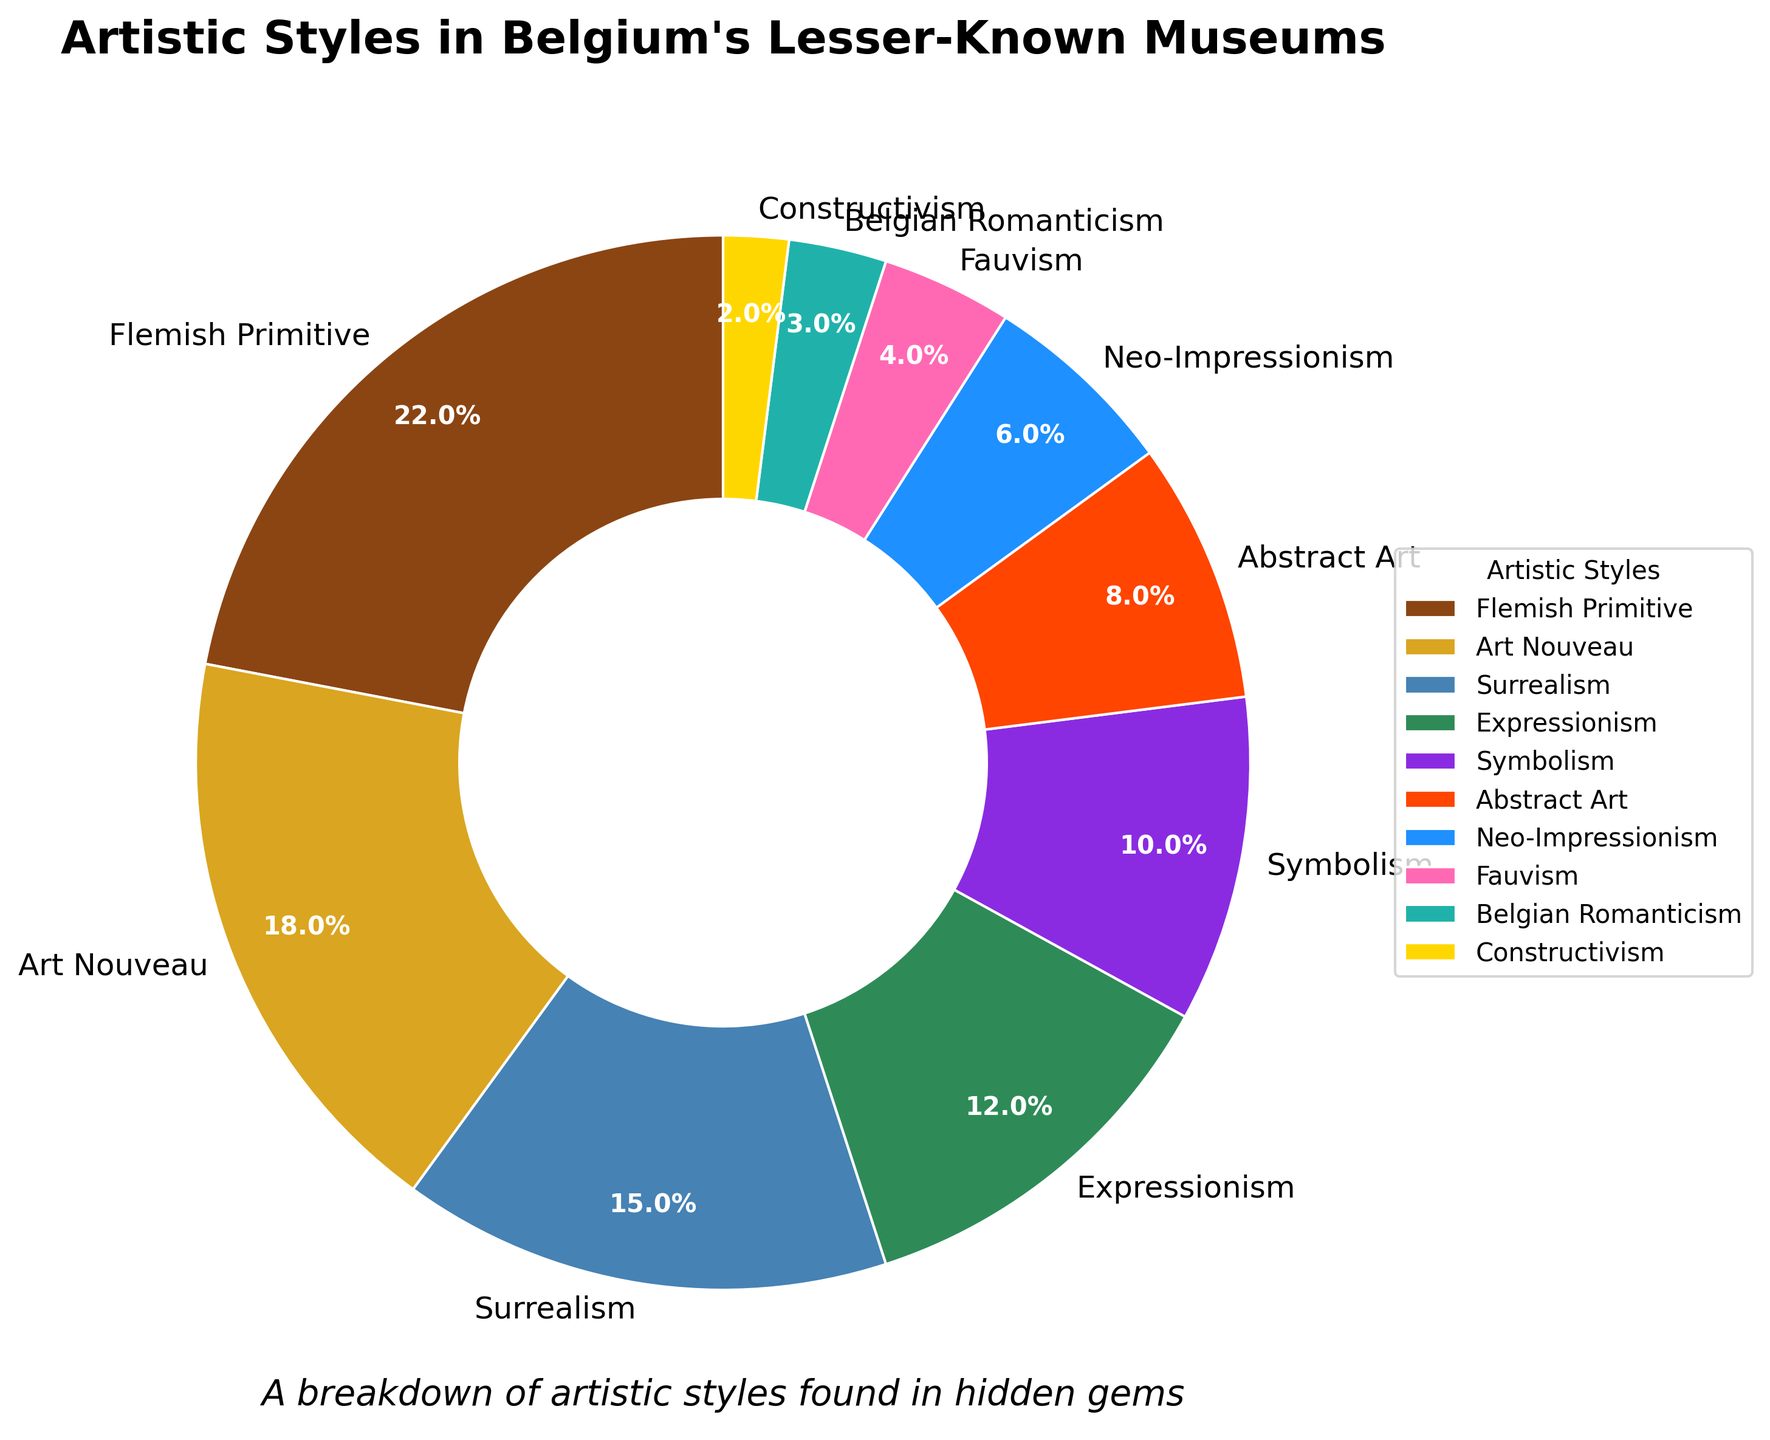What percentage of the artistic styles is represented by Flemish Primitive and Symbolism together? Add the percentages of Flemish Primitive (22%) and Symbolism (10%) to get the combined representation: 22 + 10 = 32
Answer: 32% Which artistic style has the smallest representation? By looking at the pie chart, Constructivism has the smallest percentage at 2%
Answer: Constructivism Which is more predominant in the lesser-known museums, Art Nouveau or Expressionism? Art Nouveau has a percentage of 18% and Expressionism has 12%, so Art Nouveau is more predominant
Answer: Art Nouveau How much more percentage does Surrealism have compared to Belgian Romanticism? Surrealism has 15% and Belgian Romanticism has 3%. The difference is 15 - 3 = 12
Answer: 12% What is the combined percentage of all styles that have a representation of less than 10%? The styles with less than 10% are Symbolism (10%), Abstract Art (8%), Neo-Impressionism (6%), Fauvism (4%), Belgian Romanticism (3%), and Constructivism (2%). Add them up: 10 + 8 + 6 + 4 + 3 + 2 = 33
Answer: 33% Which has a higher percentage, Fauvism or Neo-Impressionism, and by how much? Neo-Impressionism has 6% and Fauvism has 4%, so Neo-Impressionism is higher by 6 - 4 = 2
Answer: Neo-Impressionism, 2% What artistic styles make up a total of 40% if added together? Combining Expressionism (12%), Symbolism (10%), Abstract Art (8%), and Neo-Impressionism (6%), reaches a total of 40%: 12 + 10 + 8 + 6 = 36, but adding Fauvism (4%) will give a total of 40%
Answer: Expressionism, Symbolism, Abstract Art, Neo-Impressionism, Fauvism What would be the average percentage if you considered only Art Nouveau, Surrealism, and Expressionism? Add the percentages of Art Nouveau (18%), Surrealism (15%), and Expressionism (12%) together and then divide by 3: (18 + 15 + 12) / 3 = 45 / 3 = 15
Answer: 15 How much more combined percentage do Flemish Primitive and Art Nouveau have compared to Abstract Art and Neo-Impressionism? Flemish Primitive (22%) and Art Nouveau (18%) add up to 40%. Abstract Art (8%) and Neo-Impressionism (6%) add up to 14%. The difference is 40 - 14 = 26
Answer: 26% 